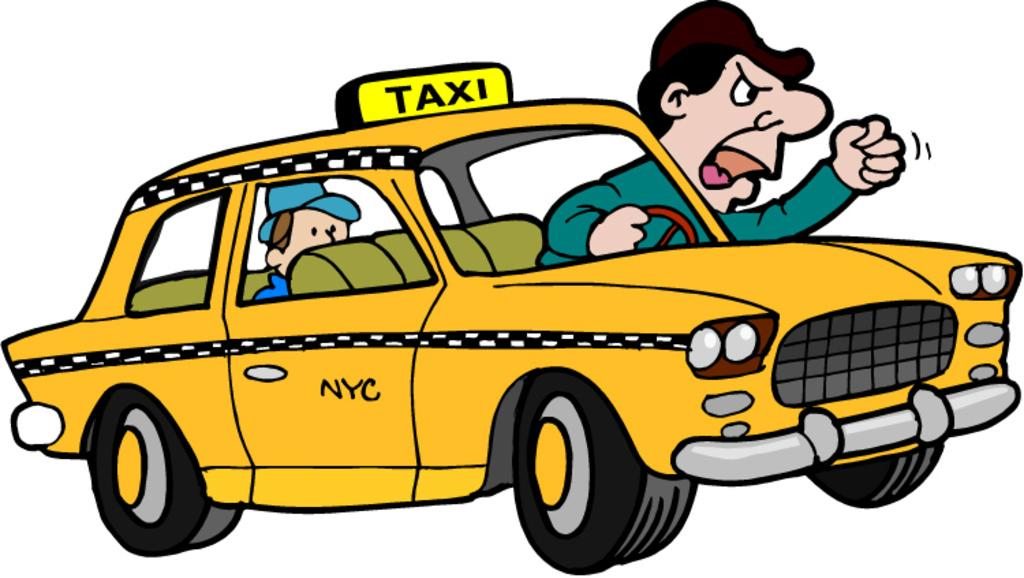<image>
Create a compact narrative representing the image presented. A cartoon image where a taxi driver leans out the window and shours 